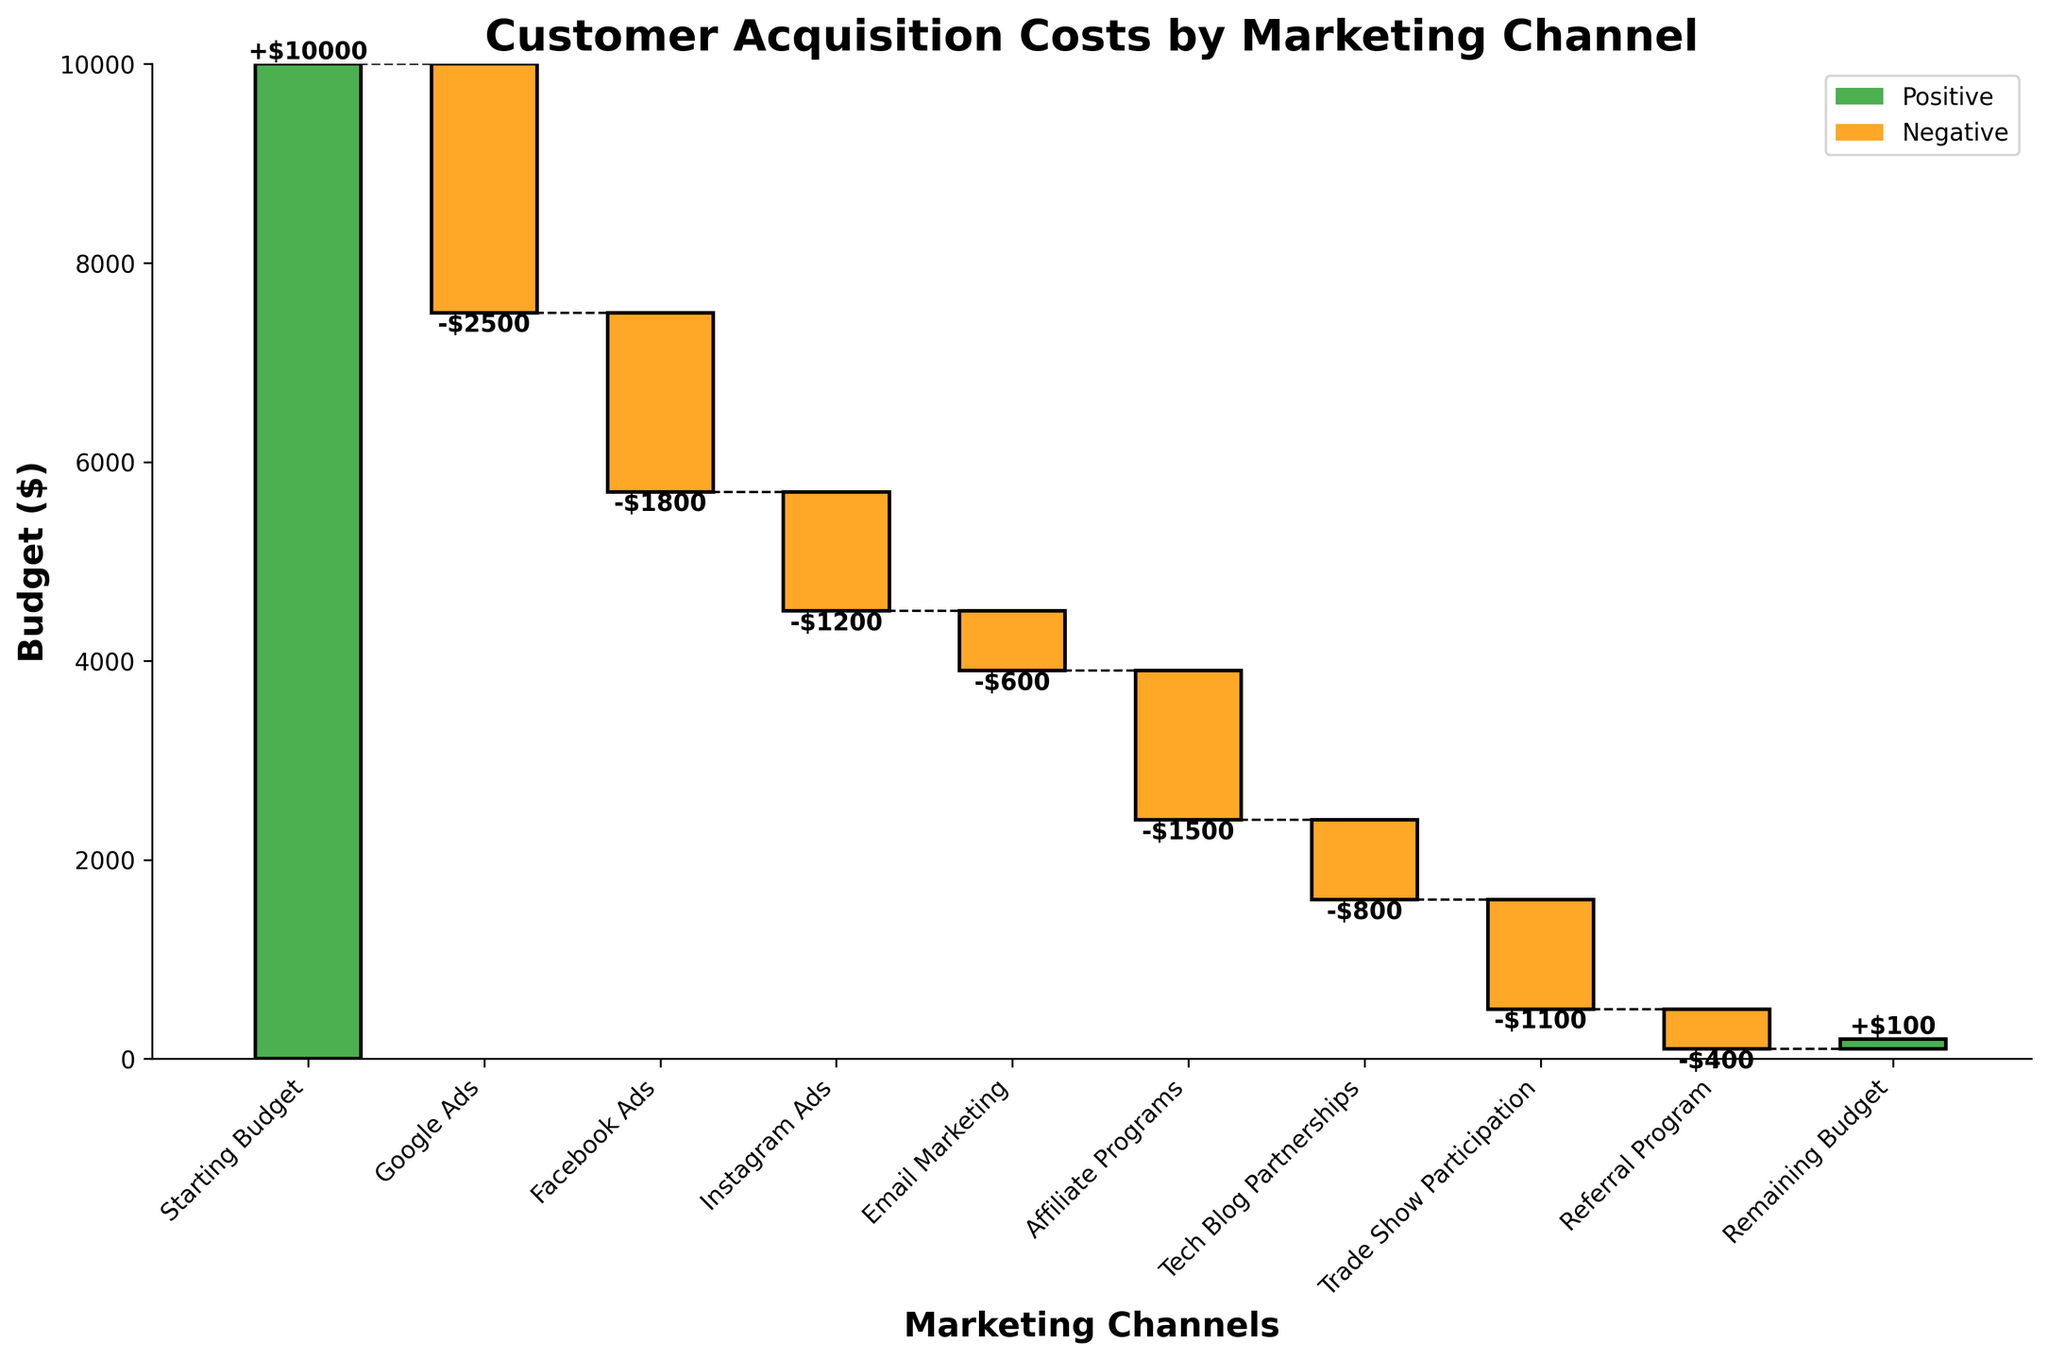How much was the starting budget for customer acquisition? The figure clearly indicates that the starting budget is labeled as "$10000" at the top of the first bar.
Answer: $10000 Which marketing channel used the highest budget? By looking at the bar chart, the Google Ads channel has the highest negative value, costing $2500, as revealed by the height of the negative bar.
Answer: Google Ads What is the cumulative cost after all marketing channels, before considering the remaining budget? Summing up the costs of all marketing channels: -2500 (Google Ads) - 1800 (Facebook Ads) - 1200 (Instagram Ads) - 600 (Email Marketing) - 1500 (Affiliate Programs) - 800 (Tech Blog Partnerships) - 1100 (Trade Show Participation) - 400 (Referral Program) = -9900. Adding this to the starting budget of $10000 leaves $100 (remaining budget).
Answer: $100 What is the difference in customer acquisition cost between Google Ads and Facebook Ads? Google Ads: -$2500, Facebook Ads: -$1800. The difference is -2500 - (-1800) = -700. Hence, Google Ads cost $700 more than Facebook Ads.
Answer: $700 Which marketing channel had the lowest budget usage? The Email Marketing channel shows the smallest negative value, which is -$600.
Answer: Email Marketing How much did the budget increase or decrease after Email Marketing? Starting Budget: $10000, up to Email Marketing: Total cost = -2500 (Google Ads) - 1800 (Facebook Ads) - 1200 (Instagram Ads) - 600 (Email Marketing) = -6100. So, the budget after Email Marketing is $10000 - $6100 = $3900.
Answer: $3900 How does the cost of Affiliate Programs compare to that of Tech Blog Partnerships? Affiliate Programs: -$1500, Tech Blog Partnerships: -$800. The cost of Affiliate Programs is higher by -1500 - (-800) = -700. Hence, Affiliate Programs cost $700 more than Tech Blog Partnerships.
Answer: Affiliate Programs cost $700 more What is the final remaining budget? By the end of all marketing channels, the final value marked in the graph is $100, indicating the remaining budget.
Answer: $100 What portion of the initial budget was used by Trade Show Participation? Trade Show Participation cost: -$1100, Initial Budget: $10000. The portion used is (1100/10000) * 100% = 11%.
Answer: 11% How much did the cumulative budget reduce by after Instagram Ads? Before Instagram Ads: Starting Budget - Google Ads - Facebook Ads = 10000 - 2500 - 1800 = $5700. After Instagram Ads: $5700 - 1200 = $4500. The cumulative budget reduced by 5700 - 4500 = $1200.
Answer: $1200 